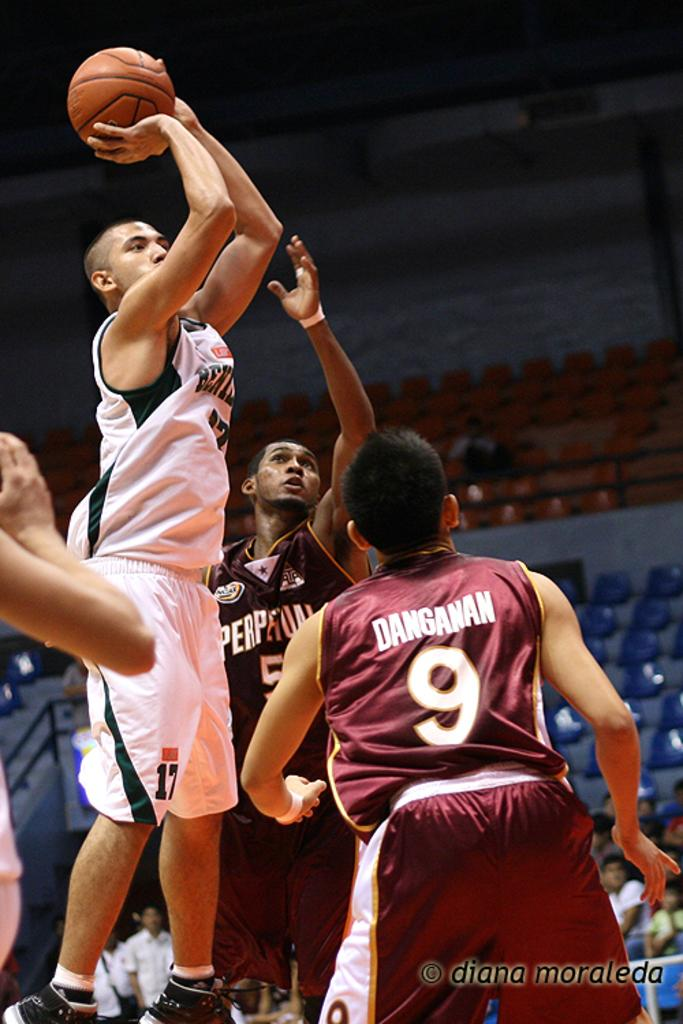Provide a one-sentence caption for the provided image. Several basketball players, including one named Danganan, are playing in a game. 